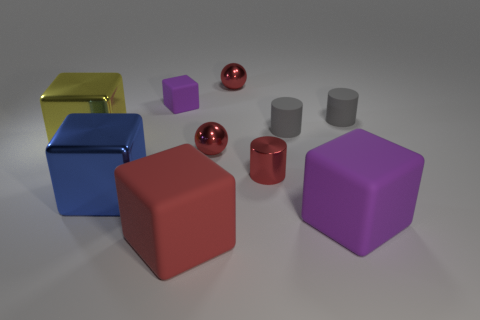Subtract all large blue shiny blocks. How many blocks are left? 4 Subtract 3 cylinders. How many cylinders are left? 0 Subtract all cylinders. How many objects are left? 7 Subtract all red cylinders. How many cylinders are left? 2 Subtract all green blocks. Subtract all yellow cylinders. How many blocks are left? 5 Subtract all cyan balls. How many blue cylinders are left? 0 Subtract all blue metal objects. Subtract all big blue cubes. How many objects are left? 8 Add 7 shiny cylinders. How many shiny cylinders are left? 8 Add 6 big blue cubes. How many big blue cubes exist? 7 Subtract 0 green cubes. How many objects are left? 10 